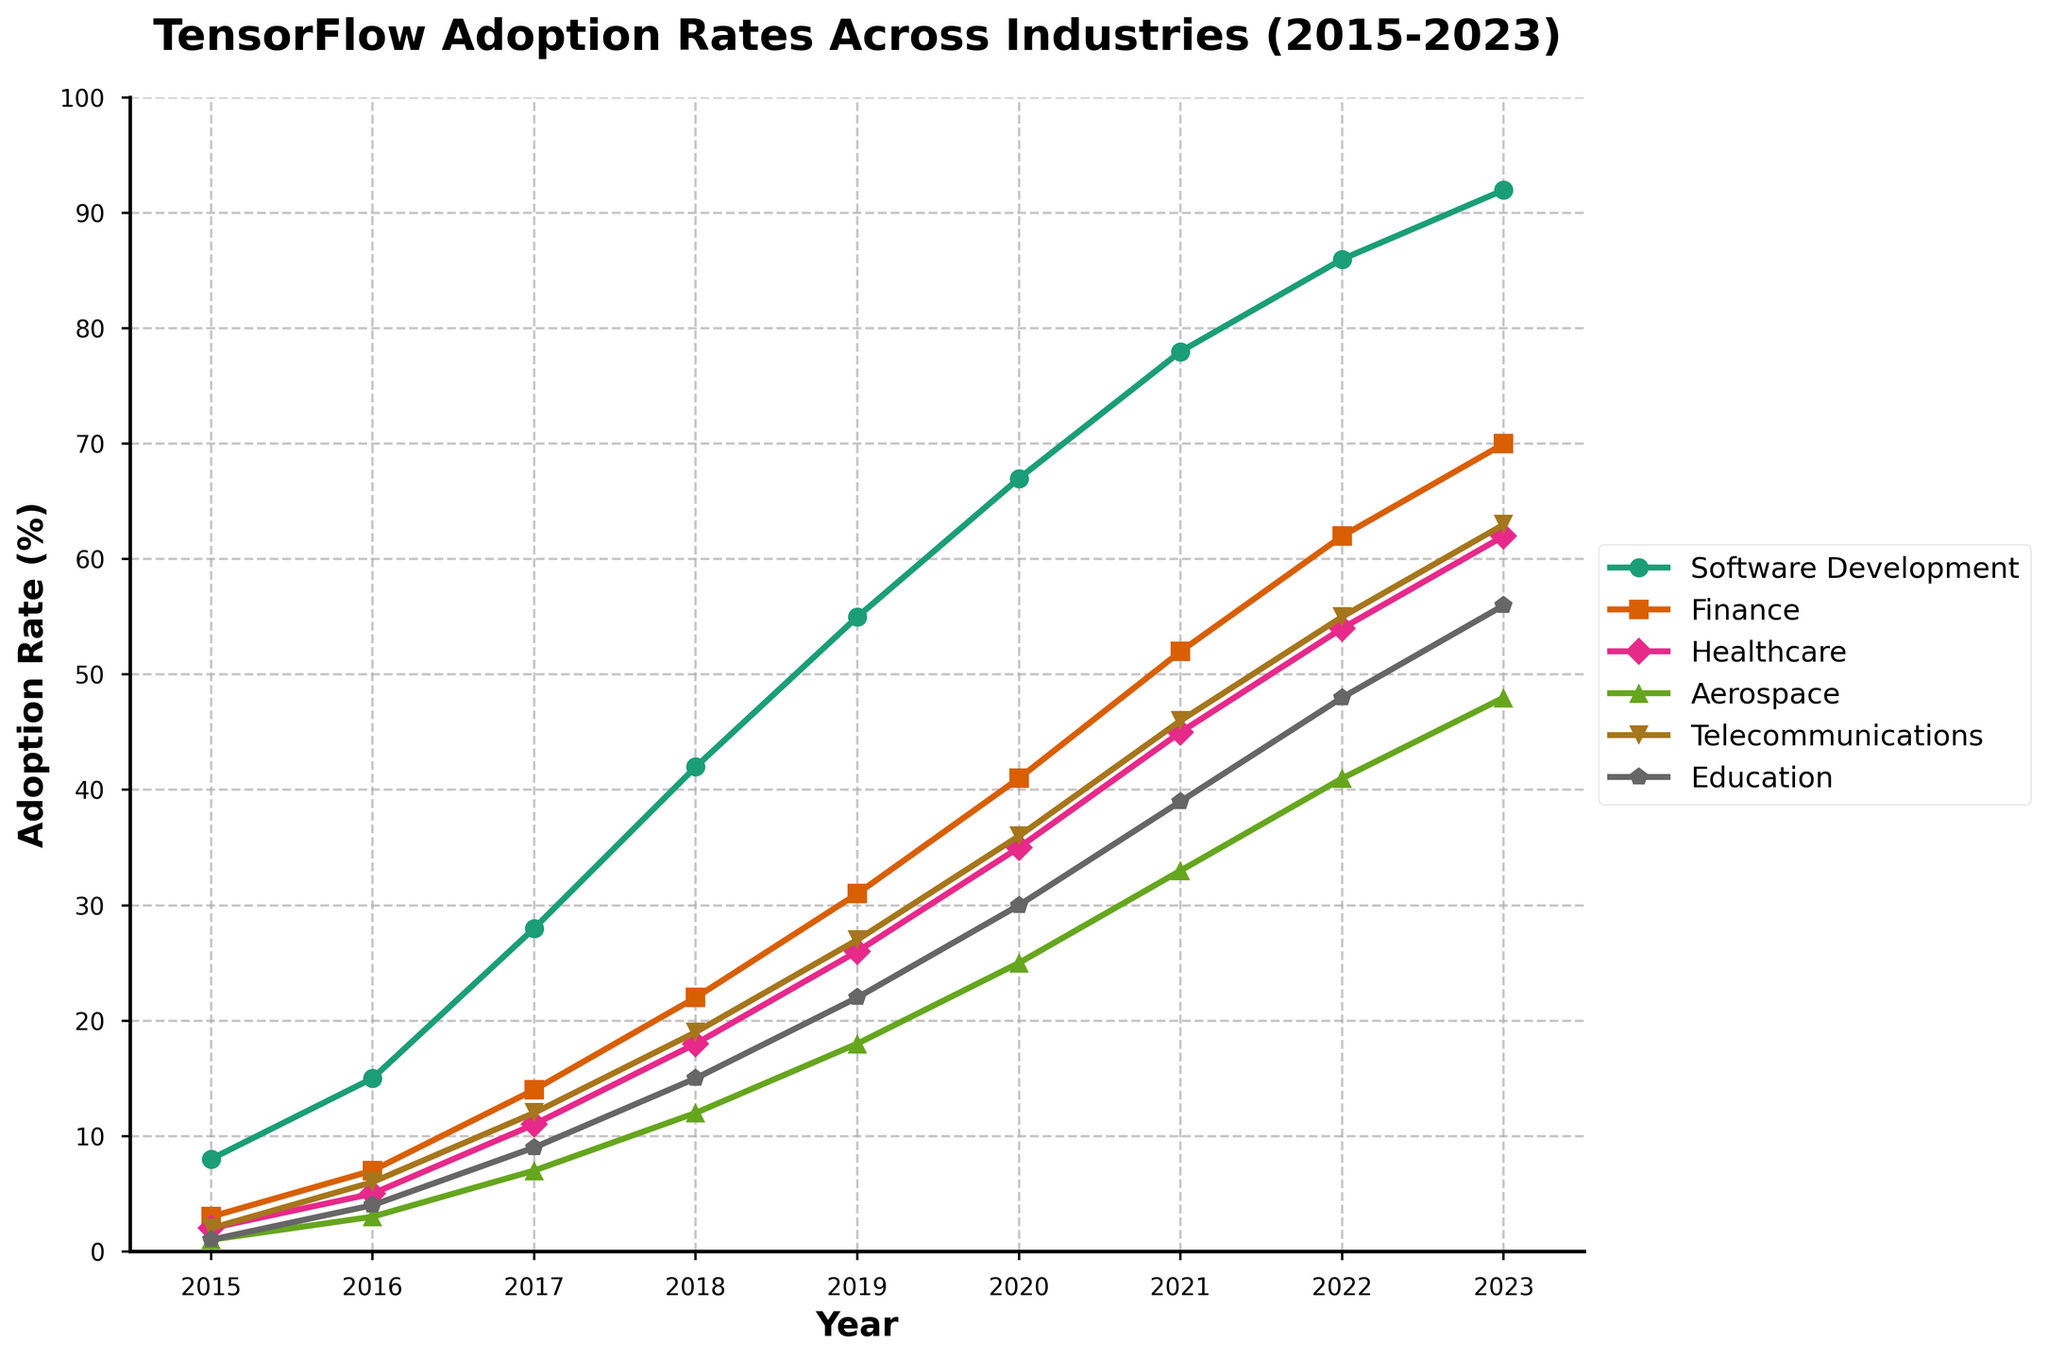What was the adoption rate of TensorFlow in the Healthcare industry in 2017? Look at the point corresponding to the Healthcare industry in 2017 and read the y-axis value.
Answer: 11% What is the average TensorFlow adoption rate in the Finance industry from 2015 to 2018? Sum the adoption rates in the Finance industry from 2015 to 2018 (3, 7, 14, 22) and then divide by the number of years (4). (3 + 7 + 14 + 22) / 4 = 46 / 4 = 11.5
Answer: 11.5% Which industry had the highest adoption rate of TensorFlow in 2023? Compare the endpoints of all the lines corresponding to 2023. The Software Development line is the highest.
Answer: Software Development How many industries had an adoption rate below 20% in 2016? Identify the lines of all industries and check which ones are below the 20% mark in 2016. Healthcare (5), Aerospace (3), Telecommunications (6), and Education (4) are all below 20%.
Answer: 4 Did the adoption rate of TensorFlow in the Aerospace industry ever exceed 20% before 2020? Look at the Aerospace industry's line from 2015 to 2019 and check if it ever goes above 20%. The line reaches only 18% in 2019.
Answer: No In which year did the Telecommunications industry surpass a 50% adoption rate? Locate the Telecommunications industry's line and find the intersection point with the 50% mark. This happens in 2021.
Answer: 2021 What is the figure's title, and why is it relevant? Identify the title positioned at the top of the figure. The title reads 'TensorFlow Adoption Rates Across Industries (2015-2023)', which is relevant as it summarizes the entire content and timeframe of the plot.
Answer: TensorFlow Adoption Rates Across Industries (2015-2023) Between which two consecutive years did the Healthcare industry see the largest increase in adoption rate? Calculate the increase in adoption rate for each consecutive year pair and identify the largest difference. The increase from 2016 to 2017 is the largest: 11 - 5 = 6.
Answer: 2016-2017 Comparing the adoption rates between 2019 and 2021, which industry saw the greatest growth? Determine the difference in adoption rates between 2019 and 2021 for each industry. Software Development: 78-55=23, Finance: 52-31=21, Healthcare: 45-26=19, Aerospace: 33-18=15, Telecommunications: 46-27=19, Education: 39-22=17. The Software Development industry saw the greatest growth.
Answer: Software Development Which industry had the smallest adoption rate variance from 2015 to 2023? Calculate the difference between the maximum and minimum values for each industry's adoption rates, and identify the smallest variance. Education: 56-1=55, Telecommunications: 63-2=61, Aerospace: 48-1=47, Healthcare: 62-2=60, Finance: 70-3=67, Software Development: 92-8=84. The Aerospace industry has the smallest variance.
Answer: Aerospace 